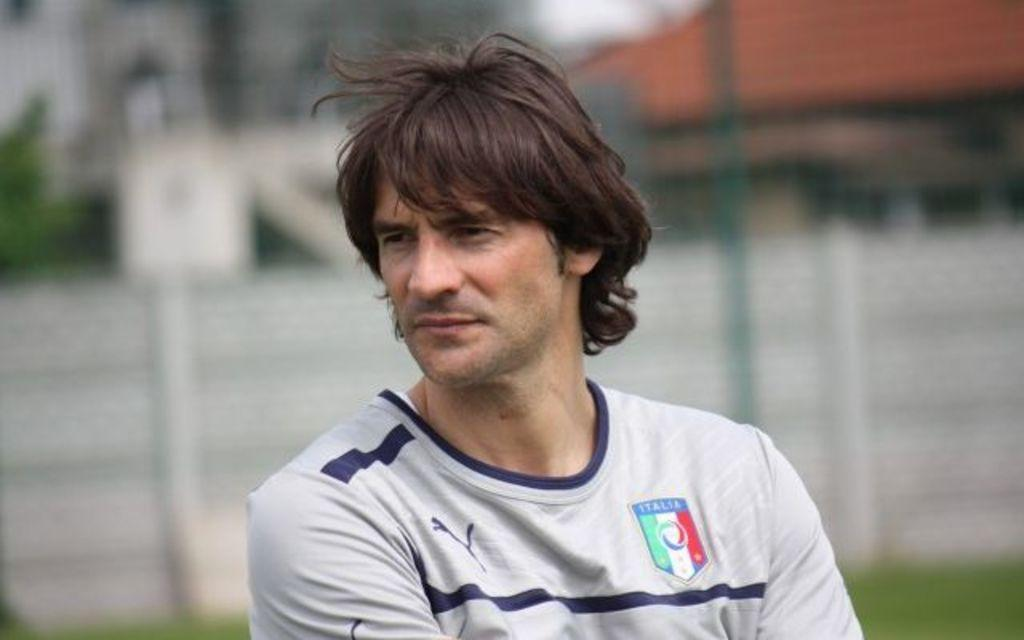<image>
Relay a brief, clear account of the picture shown. A man wearing and Italia shirt looks intense in photo. 